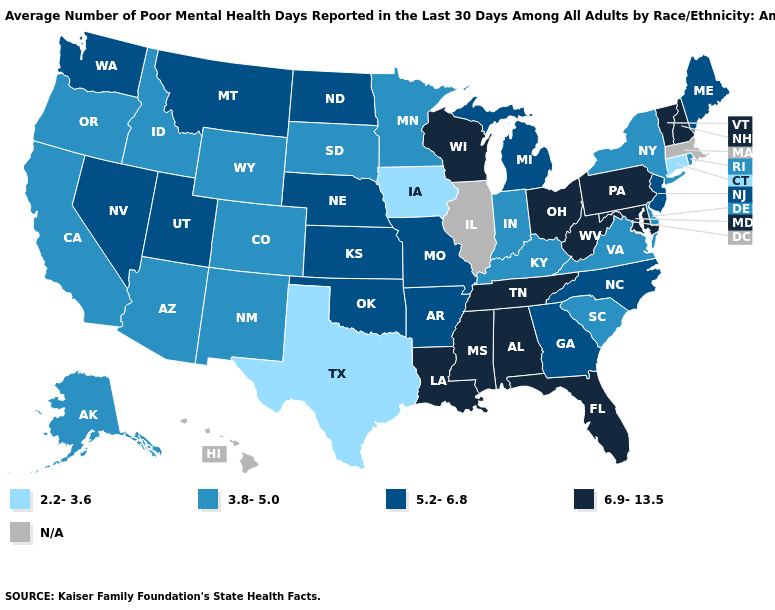Does Texas have the lowest value in the USA?
Be succinct. Yes. Name the states that have a value in the range N/A?
Answer briefly. Hawaii, Illinois, Massachusetts. How many symbols are there in the legend?
Short answer required. 5. What is the value of Iowa?
Write a very short answer. 2.2-3.6. What is the value of Illinois?
Concise answer only. N/A. What is the value of Rhode Island?
Quick response, please. 3.8-5.0. What is the lowest value in states that border Kentucky?
Write a very short answer. 3.8-5.0. Does West Virginia have the highest value in the South?
Answer briefly. Yes. Name the states that have a value in the range 3.8-5.0?
Answer briefly. Alaska, Arizona, California, Colorado, Delaware, Idaho, Indiana, Kentucky, Minnesota, New Mexico, New York, Oregon, Rhode Island, South Carolina, South Dakota, Virginia, Wyoming. Name the states that have a value in the range 2.2-3.6?
Write a very short answer. Connecticut, Iowa, Texas. What is the lowest value in states that border New Hampshire?
Concise answer only. 5.2-6.8. Name the states that have a value in the range 5.2-6.8?
Keep it brief. Arkansas, Georgia, Kansas, Maine, Michigan, Missouri, Montana, Nebraska, Nevada, New Jersey, North Carolina, North Dakota, Oklahoma, Utah, Washington. Name the states that have a value in the range 2.2-3.6?
Give a very brief answer. Connecticut, Iowa, Texas. Does the first symbol in the legend represent the smallest category?
Short answer required. Yes. 